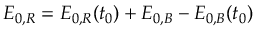Convert formula to latex. <formula><loc_0><loc_0><loc_500><loc_500>E _ { 0 , R } = E _ { 0 , R } ( t _ { 0 } ) + E _ { 0 , B } - E _ { 0 , B } ( t _ { 0 } )</formula> 